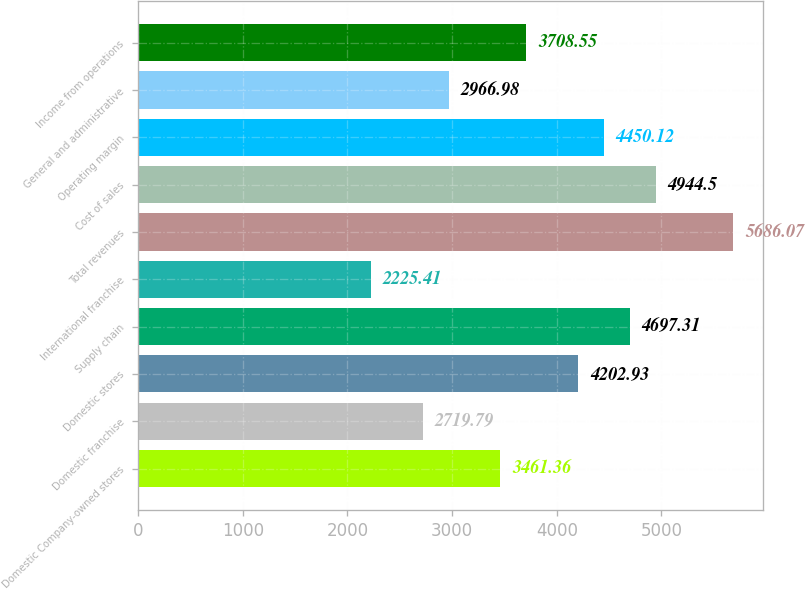Convert chart. <chart><loc_0><loc_0><loc_500><loc_500><bar_chart><fcel>Domestic Company-owned stores<fcel>Domestic franchise<fcel>Domestic stores<fcel>Supply chain<fcel>International franchise<fcel>Total revenues<fcel>Cost of sales<fcel>Operating margin<fcel>General and administrative<fcel>Income from operations<nl><fcel>3461.36<fcel>2719.79<fcel>4202.93<fcel>4697.31<fcel>2225.41<fcel>5686.07<fcel>4944.5<fcel>4450.12<fcel>2966.98<fcel>3708.55<nl></chart> 